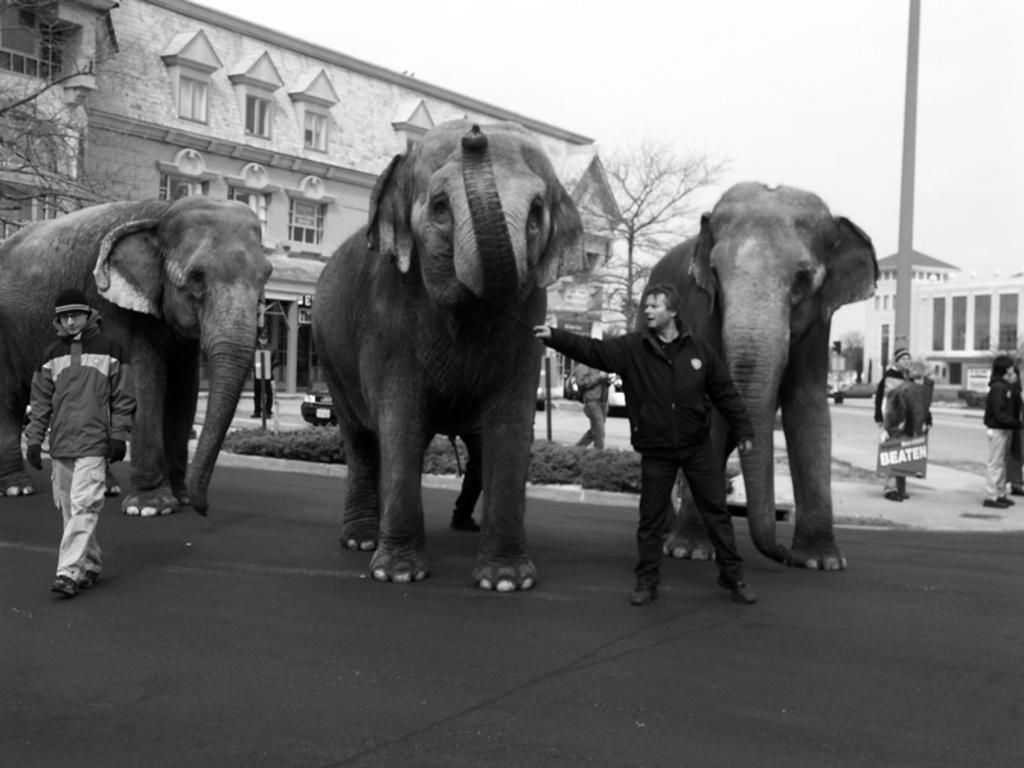What can be seen in the sky in the image? There is a sky in the image. What type of structure is present in the image? There is a building in the image. What type of plant is visible in the image? There is a dry tree in the image. Who or what is present in the image? There are people and three elephants in the image. What color is the duck in the image? There is no duck present in the image. What type of weather can be inferred from the presence of thunder in the image? There is no thunder present in the image. 